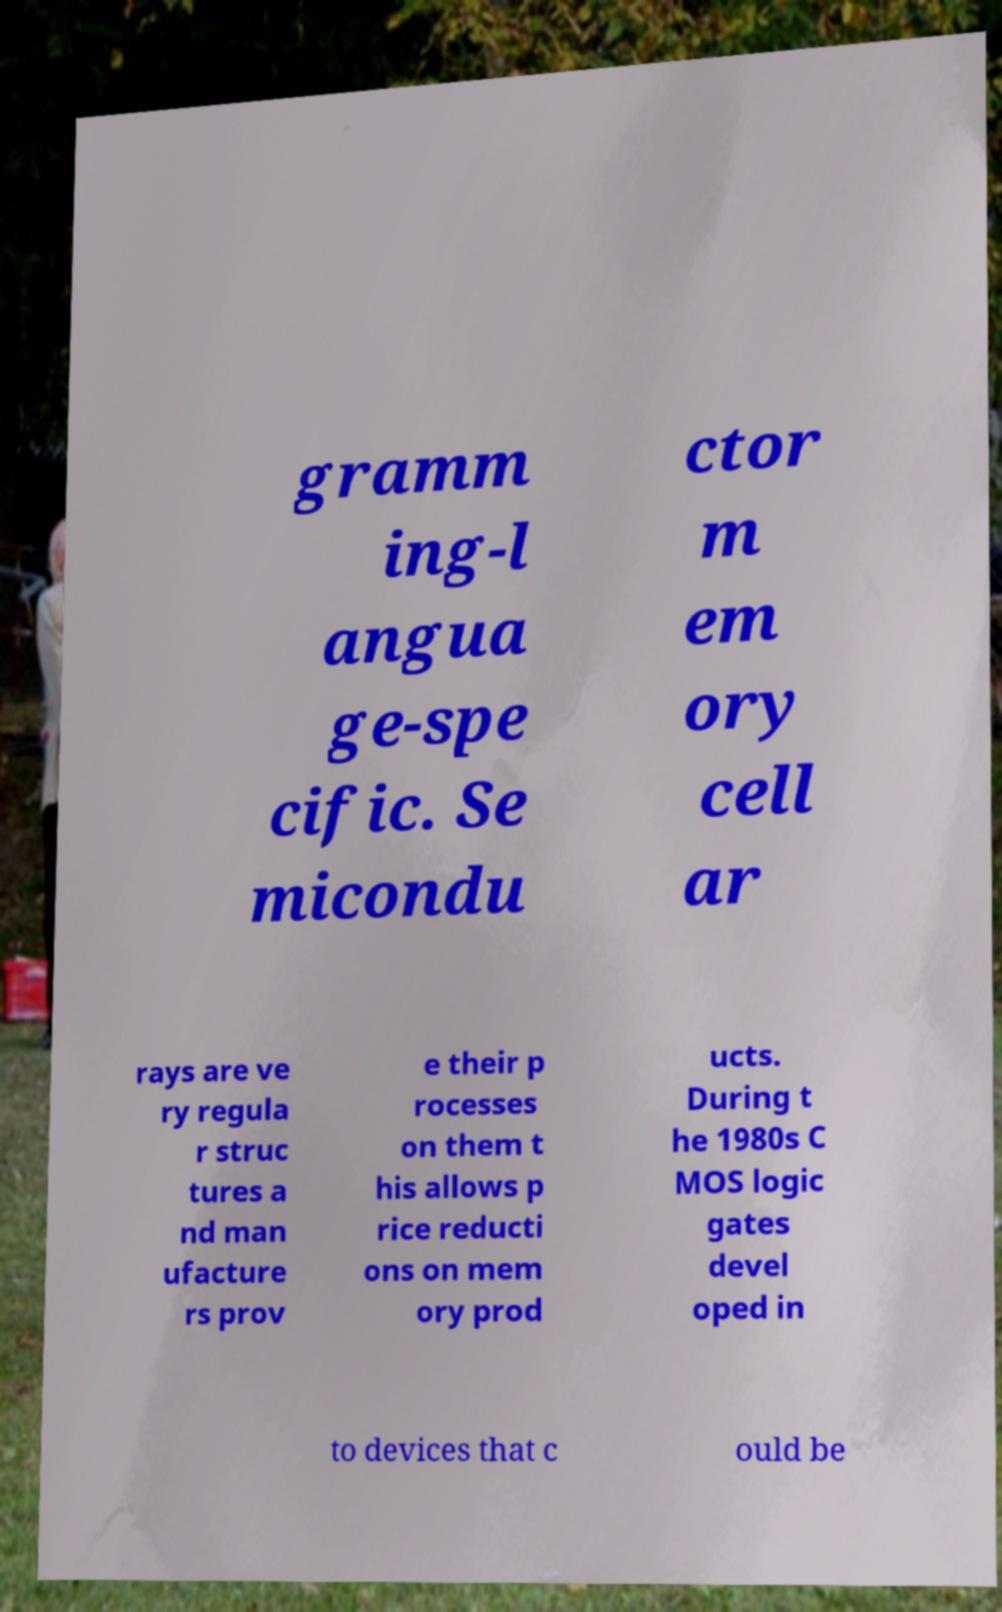What messages or text are displayed in this image? I need them in a readable, typed format. gramm ing-l angua ge-spe cific. Se micondu ctor m em ory cell ar rays are ve ry regula r struc tures a nd man ufacture rs prov e their p rocesses on them t his allows p rice reducti ons on mem ory prod ucts. During t he 1980s C MOS logic gates devel oped in to devices that c ould be 